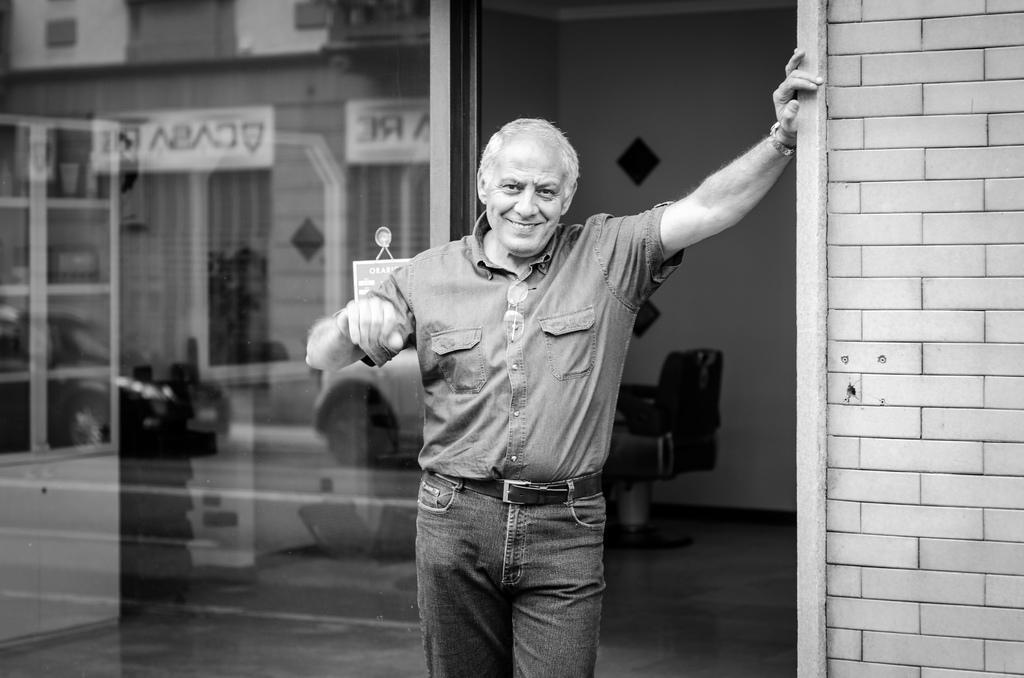Describe this image in one or two sentences. In this image we can see a person standing keeping his hands to the brick wall and in the background of the image there is a chair, glass door and wall. 